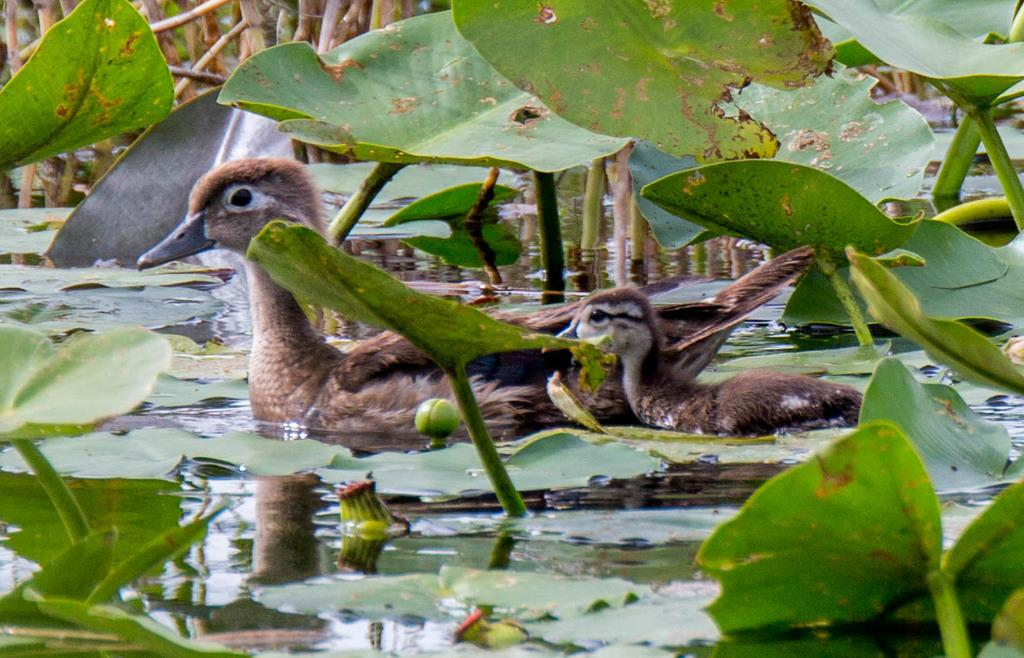What type of animals can be seen in the image? There is a duck and a duckling in the image. Where are the duck and duckling located? Both the duck and duckling are in the water. What else can be seen in the image besides the animals? There are plants visible in the image. What type of texture does the story have in the image? There is no story present in the image, so it does not have a texture. 